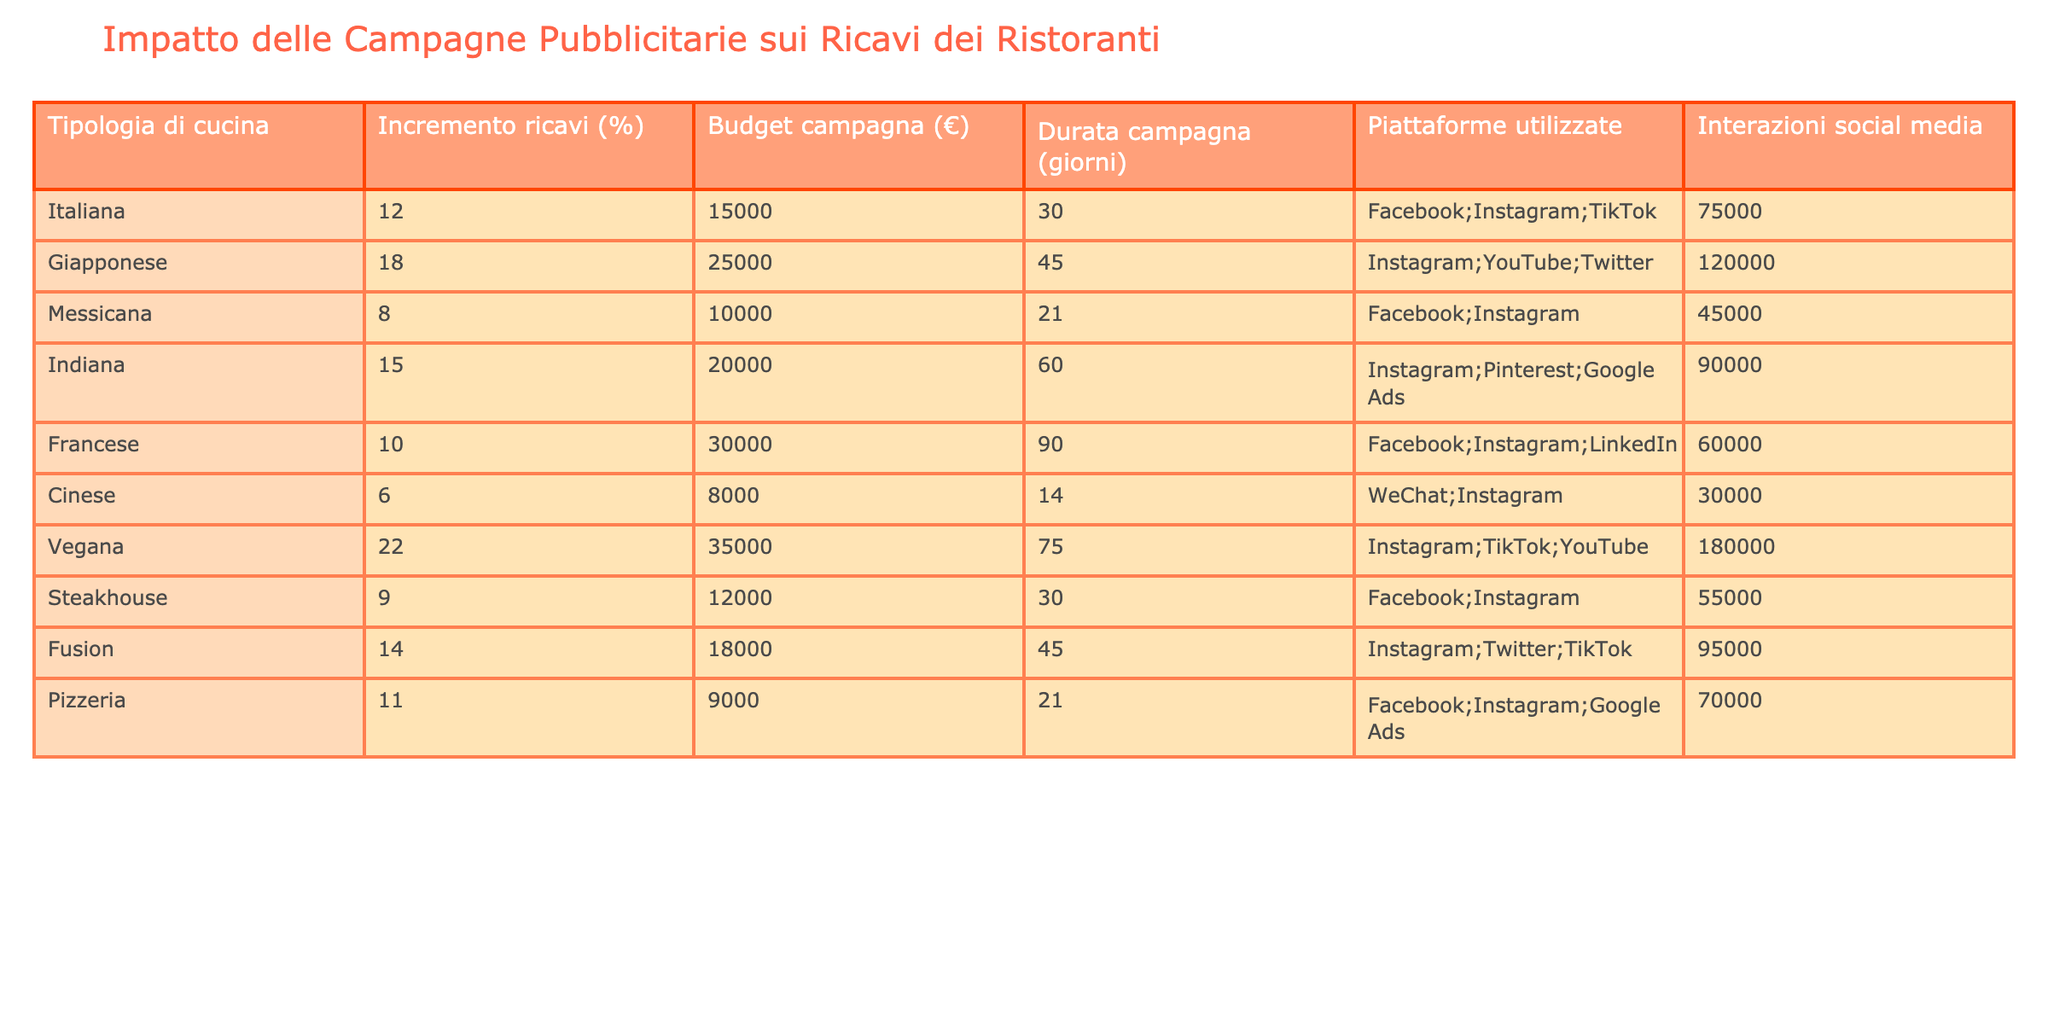Qual è l'incremento dei ricavi per la cucina vegana? Nel tavolo, cercando la riga relativa alla cucina vegana, troviamo un incremento dei ricavi pari al 22%.
Answer: 22% Qual è il budget medio delle campagne pubblicitarie per le cucine giapponese e indiana? Sommiamo i budget delle due cucine: Giapponese (25000) + Indiana (20000) = 45000. Poi dividiamo per 2: 45000 / 2 = 22500.
Answer: 22500 Quante interazioni social media ha avuto in totale la cucina messicana? Nella riga relativa alla cucina messicana, troviamo che ci sono state 45000 interazioni social media.
Answer: 45000 C'è una cucina che ha un incremento di ricavi superiore al 20%? Controllando i valori degli incrementi di ricavi, solo la cucina vegana ha un incremento del 22%, quindi la risposta è sì.
Answer: Sì Qual è la durata media delle campagne pubblicitarie per tutte le cucine? Sommiamo le durate di tutte le campagne (30 + 45 + 21 + 60 + 90 + 14 + 75 + 30 + 45 + 21) =  411. Dividiamo per il numero totale delle cucine, che è 10: 411 / 10 = 41.1 (circa 41).
Answer: 41 Qual è la cucina che ha il minor incremento di ricavi? Analizzando gli incrementi di ricavi, la cucina cinese ha il valore più basso con un incremento di 6%.
Answer: 6% Quante piattaforme di social media sono state utilizzate per la cucina indiana? Nella riga della cucina indiana, sono indicate 3 piattaforme: Instagram, Pinterest e Google Ads.
Answer: 3 Qual è la differenza di budget tra la cucina vegana e quella messicana? Per calcolare la differenza, sottraiamo il budget della cucina messicana (10000) dal budget della cucina vegana (35000): 35000 - 10000 = 25000.
Answer: 25000 Ci sono cucine che hanno avuto un incremento dei ricavi uguale a 10%? Controllando gli incrementi di ricavi, both la cucina francese e la pizzeria hanno un incremento del 10%, quindi la risposta è sì.
Answer: Sì Qual è la cucina con il maggior numero di interazioni sui social media? Osservando le interazioni social media, la cucina vegana ha 180000 interazioni, che è il numero maggiore.
Answer: Vegana Qual è la somma totale dei budget delle campagne pubblicitarie? Sommiamo i budget: 15000 + 25000 + 10000 + 20000 + 30000 + 8000 + 35000 + 12000 + 18000 + 9000 =  155000.
Answer: 155000 